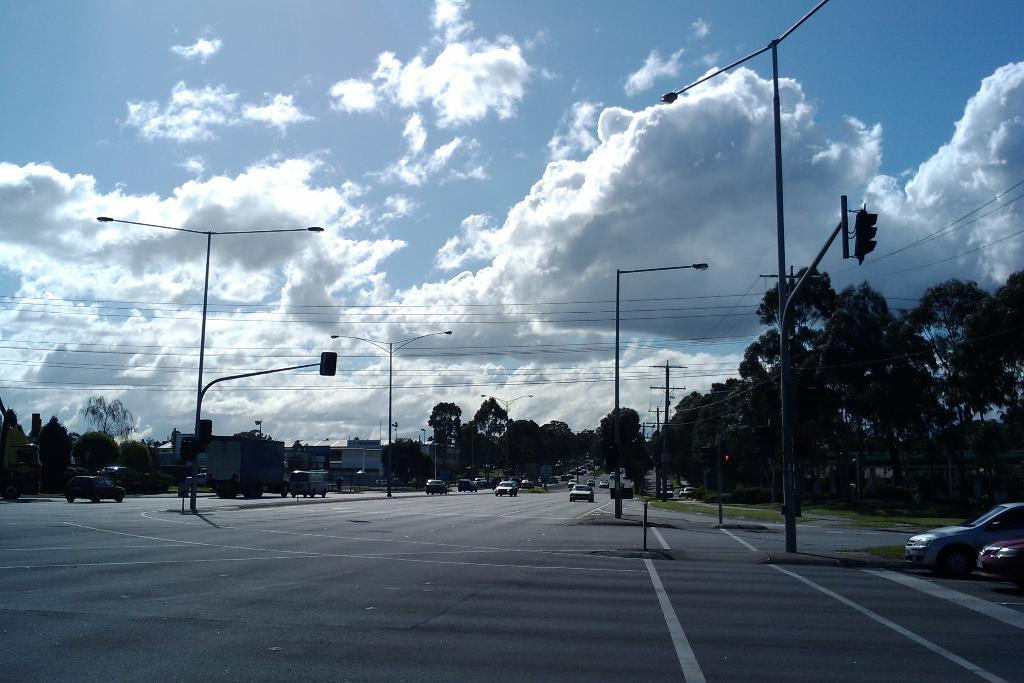What is happening on the road in the image? There are vehicles moving on the road in the image. What can be seen illuminating the road at night? There are street lights visible in the image. What type of infrastructure is visible in the background? There are roads and buildings visible in the background. How would you describe the weather based on the image? The sky is cloudy in the image. Where is the cactus located in the image? There is no cactus present in the image. What type of activity are the vehicles engaged in? The vehicles are moving on the road, which suggests they are driving or traveling. 